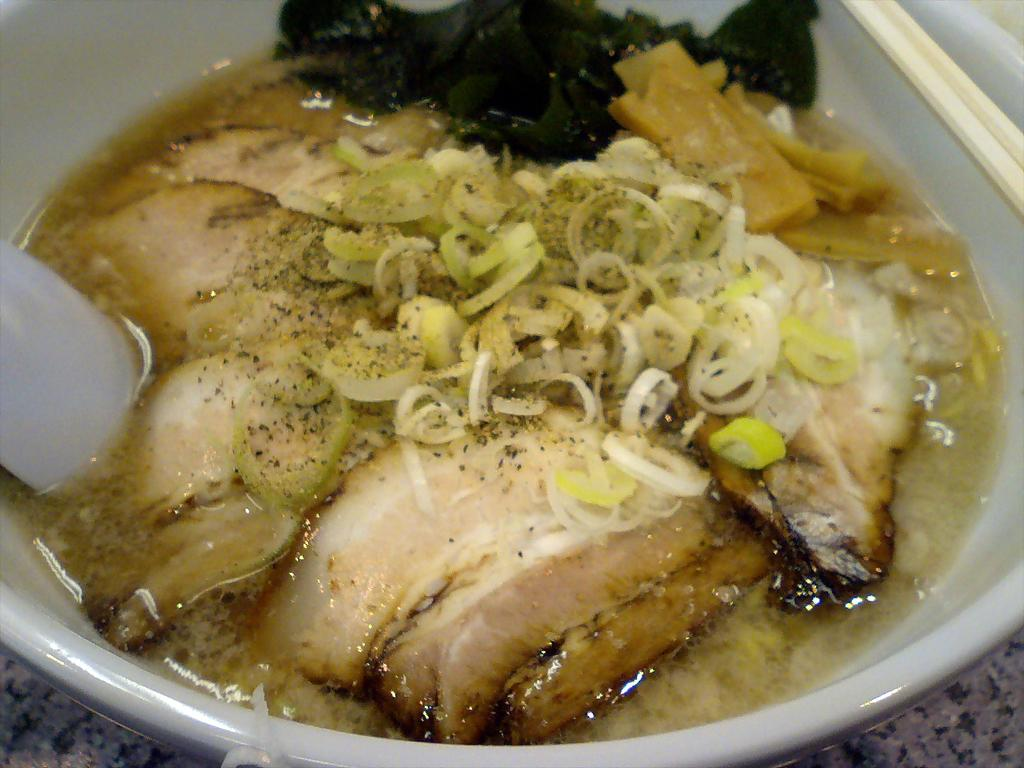What is in the bowl that is visible in the image? There is food in a bowl in the image. How many wishes does the food in the bowl grant in the image? There is no indication in the image that the food in the bowl grants wishes, as it is simply a bowl of food. 